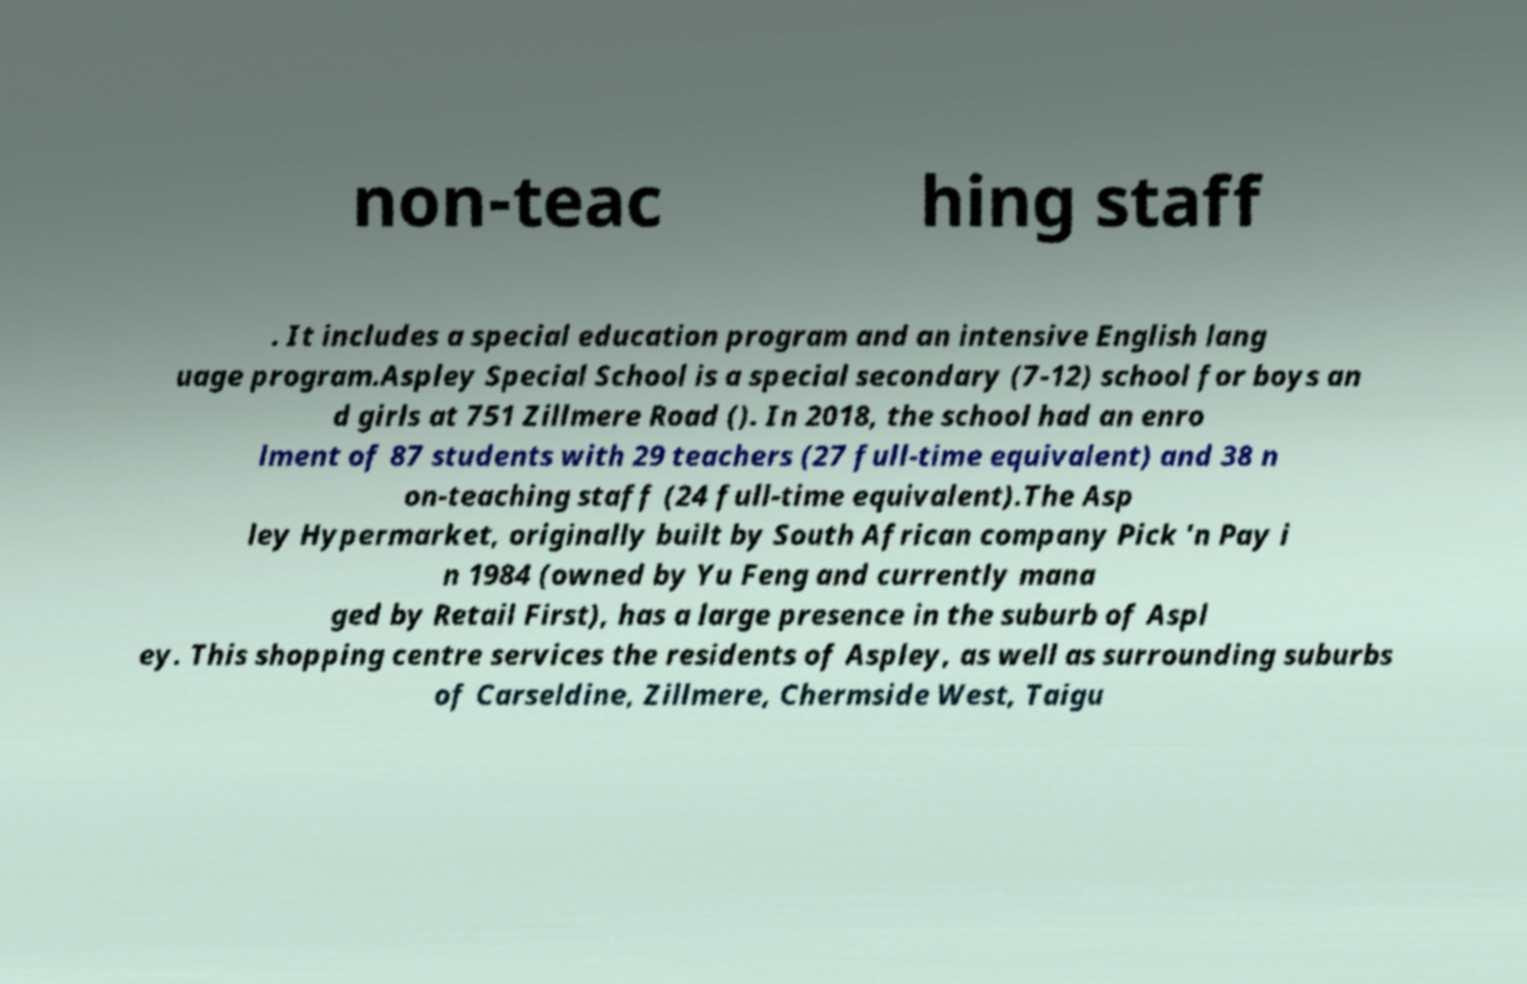There's text embedded in this image that I need extracted. Can you transcribe it verbatim? non-teac hing staff . It includes a special education program and an intensive English lang uage program.Aspley Special School is a special secondary (7-12) school for boys an d girls at 751 Zillmere Road (). In 2018, the school had an enro lment of 87 students with 29 teachers (27 full-time equivalent) and 38 n on-teaching staff (24 full-time equivalent).The Asp ley Hypermarket, originally built by South African company Pick 'n Pay i n 1984 (owned by Yu Feng and currently mana ged by Retail First), has a large presence in the suburb of Aspl ey. This shopping centre services the residents of Aspley, as well as surrounding suburbs of Carseldine, Zillmere, Chermside West, Taigu 